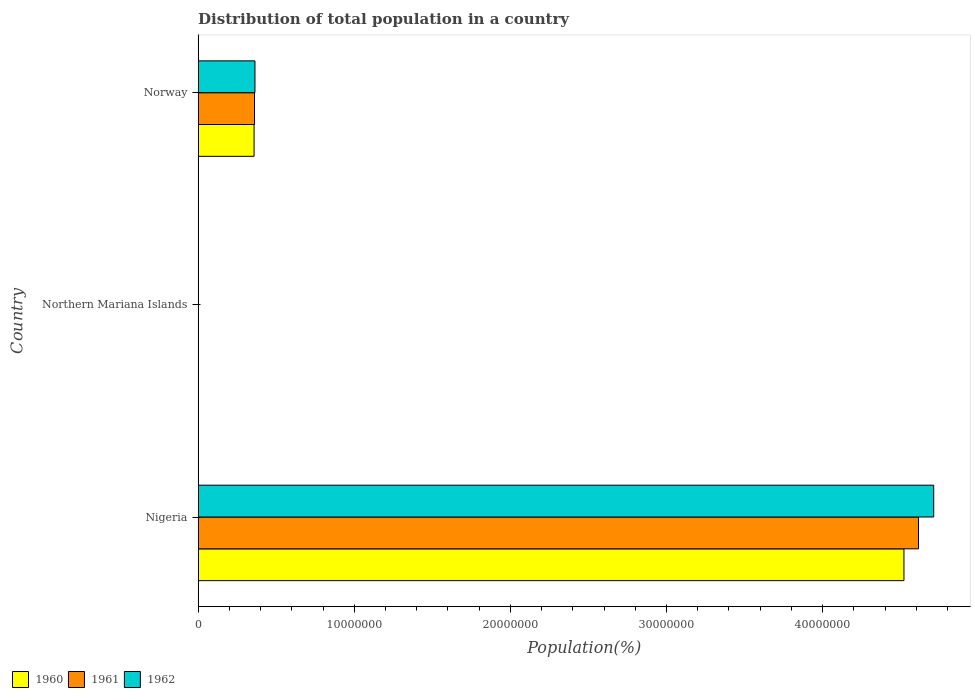Are the number of bars on each tick of the Y-axis equal?
Ensure brevity in your answer.  Yes. How many bars are there on the 2nd tick from the top?
Your answer should be very brief. 3. What is the label of the 2nd group of bars from the top?
Your response must be concise. Northern Mariana Islands. What is the population of in 1961 in Northern Mariana Islands?
Provide a short and direct response. 1.03e+04. Across all countries, what is the maximum population of in 1960?
Your answer should be very brief. 4.52e+07. Across all countries, what is the minimum population of in 1960?
Your answer should be compact. 1.01e+04. In which country was the population of in 1962 maximum?
Offer a terse response. Nigeria. In which country was the population of in 1961 minimum?
Keep it short and to the point. Northern Mariana Islands. What is the total population of in 1960 in the graph?
Your response must be concise. 4.88e+07. What is the difference between the population of in 1960 in Nigeria and that in Norway?
Give a very brief answer. 4.16e+07. What is the difference between the population of in 1960 in Northern Mariana Islands and the population of in 1962 in Norway?
Provide a succinct answer. -3.63e+06. What is the average population of in 1961 per country?
Your answer should be compact. 1.66e+07. What is the difference between the population of in 1962 and population of in 1960 in Northern Mariana Islands?
Provide a short and direct response. 471. In how many countries, is the population of in 1961 greater than 38000000 %?
Your response must be concise. 1. What is the ratio of the population of in 1962 in Nigeria to that in Northern Mariana Islands?
Give a very brief answer. 4469.96. Is the population of in 1961 in Northern Mariana Islands less than that in Norway?
Provide a succinct answer. Yes. What is the difference between the highest and the second highest population of in 1960?
Your answer should be very brief. 4.16e+07. What is the difference between the highest and the lowest population of in 1961?
Offer a very short reply. 4.61e+07. Is the sum of the population of in 1962 in Nigeria and Northern Mariana Islands greater than the maximum population of in 1960 across all countries?
Offer a very short reply. Yes. What does the 3rd bar from the top in Norway represents?
Your response must be concise. 1960. How many bars are there?
Give a very brief answer. 9. What is the difference between two consecutive major ticks on the X-axis?
Offer a very short reply. 1.00e+07. Does the graph contain any zero values?
Make the answer very short. No. Does the graph contain grids?
Offer a terse response. No. Where does the legend appear in the graph?
Offer a very short reply. Bottom left. How many legend labels are there?
Ensure brevity in your answer.  3. How are the legend labels stacked?
Your answer should be very brief. Horizontal. What is the title of the graph?
Offer a terse response. Distribution of total population in a country. What is the label or title of the X-axis?
Offer a terse response. Population(%). What is the label or title of the Y-axis?
Ensure brevity in your answer.  Country. What is the Population(%) of 1960 in Nigeria?
Provide a succinct answer. 4.52e+07. What is the Population(%) in 1961 in Nigeria?
Provide a short and direct response. 4.61e+07. What is the Population(%) of 1962 in Nigeria?
Your answer should be very brief. 4.71e+07. What is the Population(%) in 1960 in Northern Mariana Islands?
Offer a very short reply. 1.01e+04. What is the Population(%) in 1961 in Northern Mariana Islands?
Provide a succinct answer. 1.03e+04. What is the Population(%) in 1962 in Northern Mariana Islands?
Provide a short and direct response. 1.05e+04. What is the Population(%) in 1960 in Norway?
Keep it short and to the point. 3.58e+06. What is the Population(%) in 1961 in Norway?
Make the answer very short. 3.61e+06. What is the Population(%) in 1962 in Norway?
Your answer should be very brief. 3.64e+06. Across all countries, what is the maximum Population(%) of 1960?
Provide a succinct answer. 4.52e+07. Across all countries, what is the maximum Population(%) in 1961?
Keep it short and to the point. 4.61e+07. Across all countries, what is the maximum Population(%) of 1962?
Offer a very short reply. 4.71e+07. Across all countries, what is the minimum Population(%) in 1960?
Provide a succinct answer. 1.01e+04. Across all countries, what is the minimum Population(%) in 1961?
Provide a short and direct response. 1.03e+04. Across all countries, what is the minimum Population(%) of 1962?
Offer a terse response. 1.05e+04. What is the total Population(%) of 1960 in the graph?
Offer a terse response. 4.88e+07. What is the total Population(%) in 1961 in the graph?
Your answer should be very brief. 4.98e+07. What is the total Population(%) of 1962 in the graph?
Offer a terse response. 5.08e+07. What is the difference between the Population(%) of 1960 in Nigeria and that in Northern Mariana Islands?
Provide a succinct answer. 4.52e+07. What is the difference between the Population(%) of 1961 in Nigeria and that in Northern Mariana Islands?
Make the answer very short. 4.61e+07. What is the difference between the Population(%) of 1962 in Nigeria and that in Northern Mariana Islands?
Make the answer very short. 4.71e+07. What is the difference between the Population(%) in 1960 in Nigeria and that in Norway?
Give a very brief answer. 4.16e+07. What is the difference between the Population(%) of 1961 in Nigeria and that in Norway?
Your answer should be compact. 4.25e+07. What is the difference between the Population(%) of 1962 in Nigeria and that in Norway?
Give a very brief answer. 4.35e+07. What is the difference between the Population(%) in 1960 in Northern Mariana Islands and that in Norway?
Keep it short and to the point. -3.57e+06. What is the difference between the Population(%) of 1961 in Northern Mariana Islands and that in Norway?
Offer a terse response. -3.60e+06. What is the difference between the Population(%) of 1962 in Northern Mariana Islands and that in Norway?
Offer a very short reply. -3.63e+06. What is the difference between the Population(%) in 1960 in Nigeria and the Population(%) in 1961 in Northern Mariana Islands?
Your response must be concise. 4.52e+07. What is the difference between the Population(%) in 1960 in Nigeria and the Population(%) in 1962 in Northern Mariana Islands?
Provide a short and direct response. 4.52e+07. What is the difference between the Population(%) in 1961 in Nigeria and the Population(%) in 1962 in Northern Mariana Islands?
Give a very brief answer. 4.61e+07. What is the difference between the Population(%) in 1960 in Nigeria and the Population(%) in 1961 in Norway?
Provide a short and direct response. 4.16e+07. What is the difference between the Population(%) in 1960 in Nigeria and the Population(%) in 1962 in Norway?
Make the answer very short. 4.16e+07. What is the difference between the Population(%) of 1961 in Nigeria and the Population(%) of 1962 in Norway?
Offer a very short reply. 4.25e+07. What is the difference between the Population(%) of 1960 in Northern Mariana Islands and the Population(%) of 1961 in Norway?
Your answer should be very brief. -3.60e+06. What is the difference between the Population(%) of 1960 in Northern Mariana Islands and the Population(%) of 1962 in Norway?
Your answer should be very brief. -3.63e+06. What is the difference between the Population(%) of 1961 in Northern Mariana Islands and the Population(%) of 1962 in Norway?
Your response must be concise. -3.63e+06. What is the average Population(%) in 1960 per country?
Your response must be concise. 1.63e+07. What is the average Population(%) in 1961 per country?
Offer a terse response. 1.66e+07. What is the average Population(%) in 1962 per country?
Your answer should be very brief. 1.69e+07. What is the difference between the Population(%) in 1960 and Population(%) in 1961 in Nigeria?
Provide a short and direct response. -9.33e+05. What is the difference between the Population(%) in 1960 and Population(%) in 1962 in Nigeria?
Keep it short and to the point. -1.91e+06. What is the difference between the Population(%) of 1961 and Population(%) of 1962 in Nigeria?
Your answer should be compact. -9.74e+05. What is the difference between the Population(%) in 1960 and Population(%) in 1961 in Northern Mariana Islands?
Provide a short and direct response. -270. What is the difference between the Population(%) in 1960 and Population(%) in 1962 in Northern Mariana Islands?
Give a very brief answer. -471. What is the difference between the Population(%) in 1961 and Population(%) in 1962 in Northern Mariana Islands?
Offer a terse response. -201. What is the difference between the Population(%) of 1960 and Population(%) of 1961 in Norway?
Give a very brief answer. -2.86e+04. What is the difference between the Population(%) in 1960 and Population(%) in 1962 in Norway?
Your answer should be compact. -5.77e+04. What is the difference between the Population(%) of 1961 and Population(%) of 1962 in Norway?
Your answer should be very brief. -2.91e+04. What is the ratio of the Population(%) of 1960 in Nigeria to that in Northern Mariana Islands?
Your answer should be very brief. 4489.73. What is the ratio of the Population(%) of 1961 in Nigeria to that in Northern Mariana Islands?
Give a very brief answer. 4462.68. What is the ratio of the Population(%) of 1962 in Nigeria to that in Northern Mariana Islands?
Give a very brief answer. 4469.96. What is the ratio of the Population(%) of 1960 in Nigeria to that in Norway?
Make the answer very short. 12.62. What is the ratio of the Population(%) in 1961 in Nigeria to that in Norway?
Your response must be concise. 12.78. What is the ratio of the Population(%) in 1962 in Nigeria to that in Norway?
Make the answer very short. 12.95. What is the ratio of the Population(%) in 1960 in Northern Mariana Islands to that in Norway?
Your answer should be very brief. 0. What is the ratio of the Population(%) of 1961 in Northern Mariana Islands to that in Norway?
Your response must be concise. 0. What is the ratio of the Population(%) in 1962 in Northern Mariana Islands to that in Norway?
Keep it short and to the point. 0. What is the difference between the highest and the second highest Population(%) of 1960?
Offer a very short reply. 4.16e+07. What is the difference between the highest and the second highest Population(%) of 1961?
Ensure brevity in your answer.  4.25e+07. What is the difference between the highest and the second highest Population(%) in 1962?
Offer a terse response. 4.35e+07. What is the difference between the highest and the lowest Population(%) in 1960?
Your response must be concise. 4.52e+07. What is the difference between the highest and the lowest Population(%) of 1961?
Give a very brief answer. 4.61e+07. What is the difference between the highest and the lowest Population(%) of 1962?
Provide a short and direct response. 4.71e+07. 